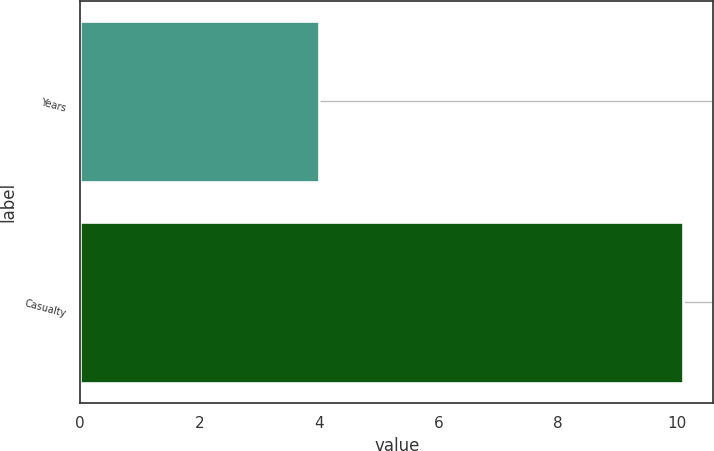<chart> <loc_0><loc_0><loc_500><loc_500><bar_chart><fcel>Years<fcel>Casualty<nl><fcel>4<fcel>10.1<nl></chart> 